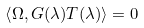Convert formula to latex. <formula><loc_0><loc_0><loc_500><loc_500>\left \langle \Omega , G ( \lambda ) T ( \lambda ) \right \rangle = 0</formula> 